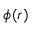Convert formula to latex. <formula><loc_0><loc_0><loc_500><loc_500>\phi ( r )</formula> 